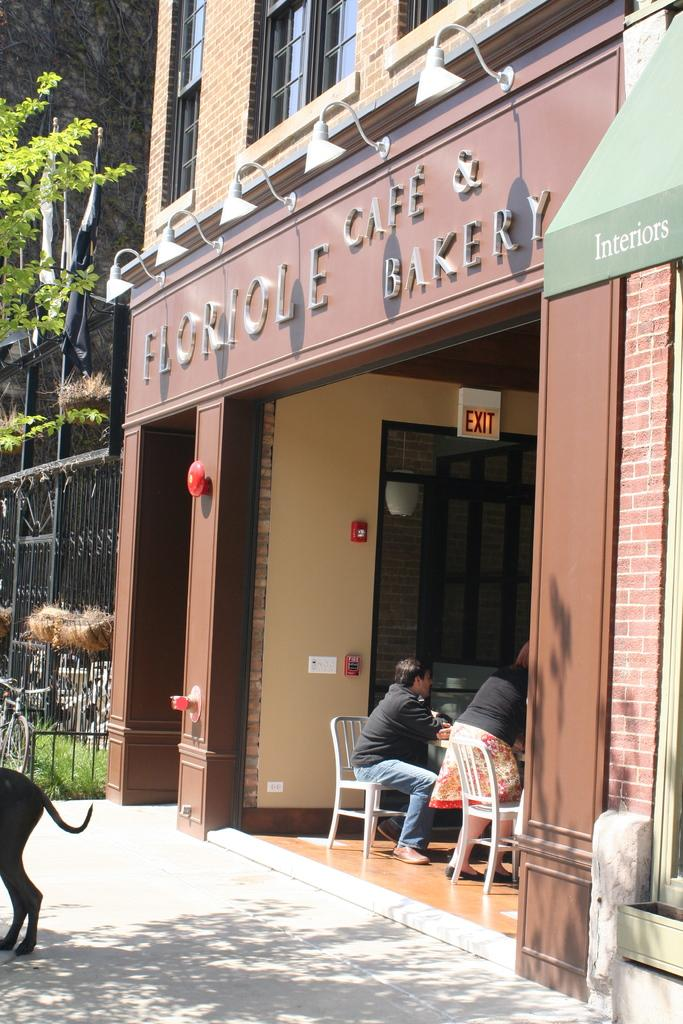What type of structure is present in the image? There is a building in the image. What are the two persons in the building doing? The two persons are sitting in chairs in the building. What can be seen in the background of the image? There are trees visible in the image. What type of substance is being played on the drum in the image? There is no drum or substance present in the image. How many cars can be seen parked near the building in the image? There is no mention of cars in the image; only a building, two persons, and trees are visible. 